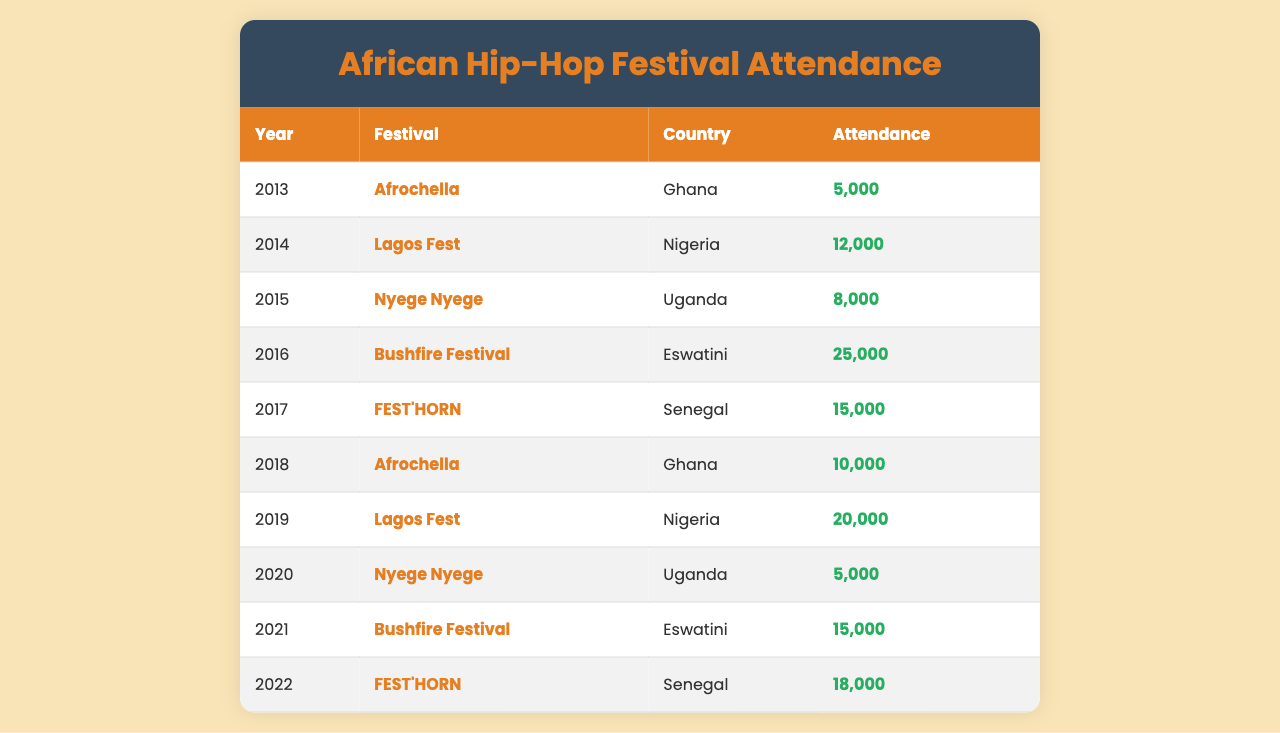What was the highest attendance at a festival in Eswatini? The table shows that the Bushfire Festival in Eswatini had an attendance of 25,000 in 2016, which is the highest amongst the listed festivals for that country.
Answer: 25,000 Which festival had the lowest attendance in the last decade? In the table, both the Afrochella festival in 2013 and the Nyege Nyege festival in 2020 had the lowest attendance of 5,000.
Answer: 5,000 What year saw the highest attendance in Ghana's Afrochella festival? Comparing the attendance figures for Afrochella, it was in 2018 when the attendance reached 10,000, which is the highest for that festival at that location in the decade.
Answer: 10,000 Which country hosted the festival with the highest overall attendance in the decade? The highest attendance recorded in the decade was in Eswatini for the Bushfire Festival with 25,000 attendees in 2016. Thus, Eswatini had the festival with the highest attendance.
Answer: Eswatini How many total attendees were there at festivals in Nigeria over the last decade? Nigeria hosted two festivals, with attendance figures of 12,000 in 2014 and 20,000 in 2019. Summing these gives a total of 12,000 + 20,000 = 32,000 attendees.
Answer: 32,000 Did the attendance at the Nyege Nyege festival increase from 2015 to 2020? Comparing the figures, the Nyege Nyege festival had an attendance of 8,000 in 2015 and then decreased to 5,000 in 2020, indicating a drop in attendance.
Answer: No What was the average attendance at the FEST'HORN festival across the years it took place? FEST'HORN took place in Senegal in 2017 and 2022 with attendances of 15,000 and 18,000 respectively. The average can be calculated as (15,000 + 18,000) / 2 = 16,500.
Answer: 16,500 Did any festival in Uganda have more attendees than the festivals in Senegal? The P table shows that the Nyege Nyege festival in Uganda had an attendance of 8,000 in 2015 and 5,000 in 2020, while the FEST'HORN festival in Senegal had attendances of 15,000 in 2017 and 18,000 in 2022. Hence, none of the festivals in Uganda surpassed the attendance in Senegal.
Answer: No Which year had the largest increase in attendance compared to the previous year, and what was the increase? In 2019, Lagos Fest attendance rose from 12,000 (2014) to 20,000 while in the previous year (2018), attendance was 10,000 resulting in the largest increase of 10,000 from 2018 to 2019.
Answer: 10,000 in 2019 What percentage of attendees at the Bushfire Festival in 2016 does 15,000 attendees in 2021 represent? The 2016 Bushfire Festival had 25,000 attendees, and 15,000 in 2021 is (15,000 / 25,000) * 100 = 60%. Therefore, attendance in 2021 was 60% of the 2016 figure.
Answer: 60% Which country had festivals with consistently increasing attendance from 2013 to the present? Reviewing the data, Nigeria's attendance increased from 12,000 in 2014 to 20,000 in 2019, showing a consistent increase. However, Ghana's attendance increased from 5,000 in 2013 to 10,000 in 2018 but does not reflect overall consistent growth beyond that year.
Answer: Nigeria 